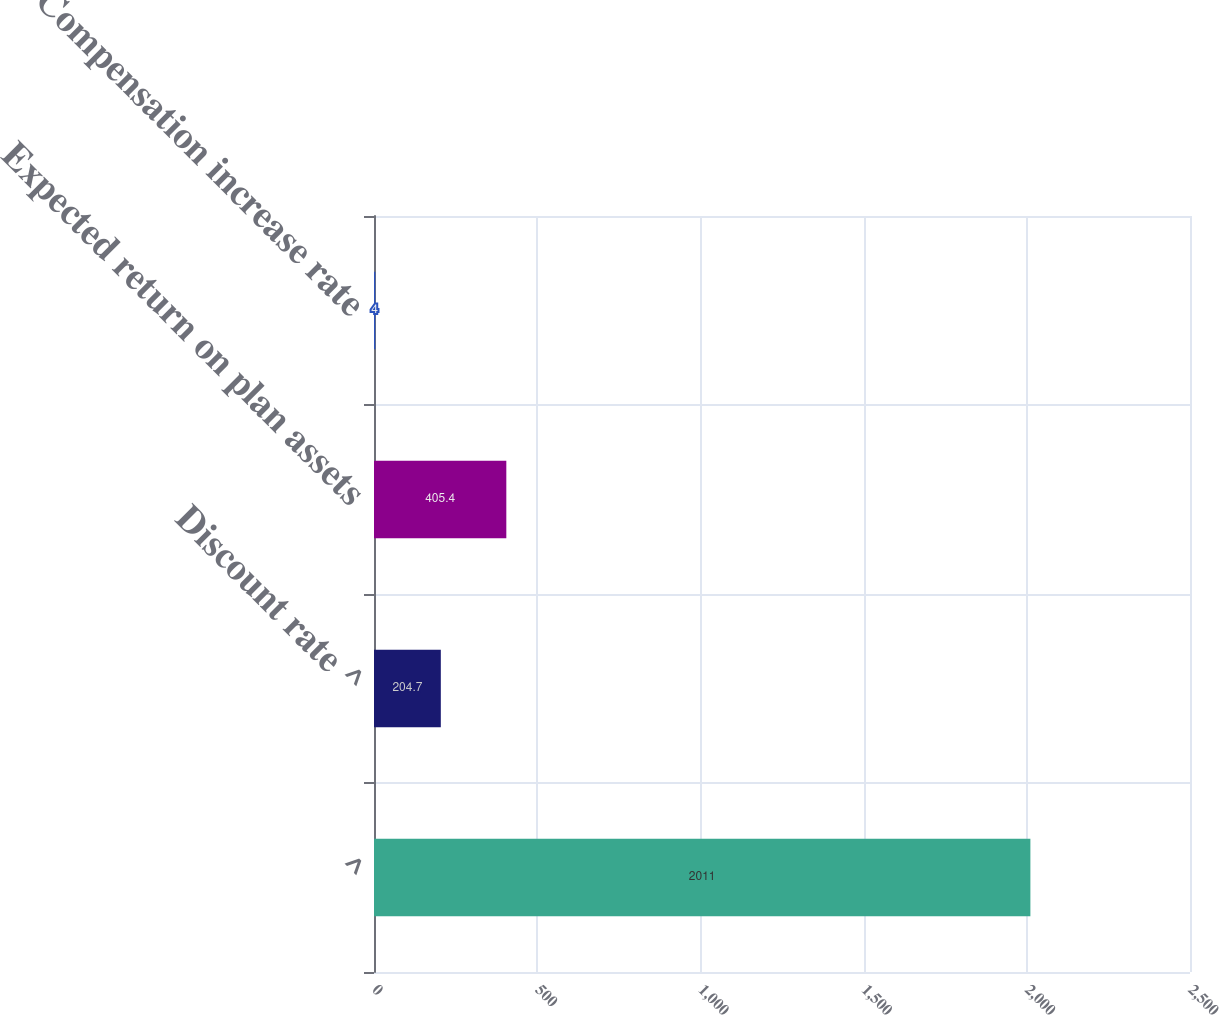Convert chart. <chart><loc_0><loc_0><loc_500><loc_500><bar_chart><fcel>^<fcel>Discount rate ^<fcel>Expected return on plan assets<fcel>Compensation increase rate<nl><fcel>2011<fcel>204.7<fcel>405.4<fcel>4<nl></chart> 